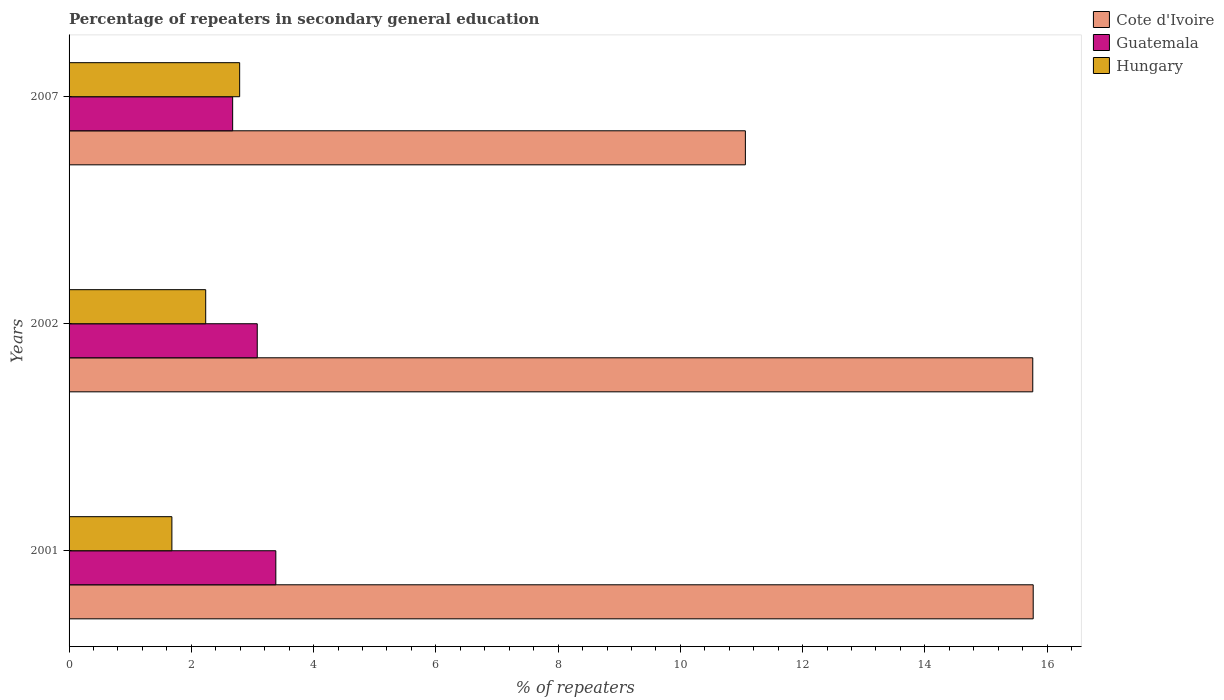How many different coloured bars are there?
Make the answer very short. 3. Are the number of bars per tick equal to the number of legend labels?
Ensure brevity in your answer.  Yes. How many bars are there on the 3rd tick from the top?
Provide a short and direct response. 3. How many bars are there on the 1st tick from the bottom?
Ensure brevity in your answer.  3. What is the percentage of repeaters in secondary general education in Cote d'Ivoire in 2002?
Give a very brief answer. 15.77. Across all years, what is the maximum percentage of repeaters in secondary general education in Hungary?
Your answer should be compact. 2.79. Across all years, what is the minimum percentage of repeaters in secondary general education in Hungary?
Give a very brief answer. 1.68. In which year was the percentage of repeaters in secondary general education in Hungary maximum?
Provide a succinct answer. 2007. What is the total percentage of repeaters in secondary general education in Guatemala in the graph?
Offer a very short reply. 9.14. What is the difference between the percentage of repeaters in secondary general education in Hungary in 2001 and that in 2007?
Provide a short and direct response. -1.11. What is the difference between the percentage of repeaters in secondary general education in Hungary in 2007 and the percentage of repeaters in secondary general education in Guatemala in 2001?
Ensure brevity in your answer.  -0.59. What is the average percentage of repeaters in secondary general education in Hungary per year?
Your response must be concise. 2.24. In the year 2002, what is the difference between the percentage of repeaters in secondary general education in Hungary and percentage of repeaters in secondary general education in Cote d'Ivoire?
Offer a very short reply. -13.53. What is the ratio of the percentage of repeaters in secondary general education in Cote d'Ivoire in 2002 to that in 2007?
Provide a short and direct response. 1.42. Is the percentage of repeaters in secondary general education in Guatemala in 2001 less than that in 2002?
Your answer should be compact. No. What is the difference between the highest and the second highest percentage of repeaters in secondary general education in Cote d'Ivoire?
Your response must be concise. 0.01. What is the difference between the highest and the lowest percentage of repeaters in secondary general education in Guatemala?
Provide a short and direct response. 0.71. In how many years, is the percentage of repeaters in secondary general education in Hungary greater than the average percentage of repeaters in secondary general education in Hungary taken over all years?
Your answer should be very brief. 1. What does the 3rd bar from the top in 2007 represents?
Offer a very short reply. Cote d'Ivoire. What does the 2nd bar from the bottom in 2002 represents?
Offer a terse response. Guatemala. Is it the case that in every year, the sum of the percentage of repeaters in secondary general education in Hungary and percentage of repeaters in secondary general education in Cote d'Ivoire is greater than the percentage of repeaters in secondary general education in Guatemala?
Provide a succinct answer. Yes. Are all the bars in the graph horizontal?
Make the answer very short. Yes. How many years are there in the graph?
Ensure brevity in your answer.  3. What is the difference between two consecutive major ticks on the X-axis?
Offer a terse response. 2. Does the graph contain any zero values?
Your answer should be very brief. No. Where does the legend appear in the graph?
Your answer should be very brief. Top right. How are the legend labels stacked?
Your answer should be very brief. Vertical. What is the title of the graph?
Ensure brevity in your answer.  Percentage of repeaters in secondary general education. Does "Mali" appear as one of the legend labels in the graph?
Offer a terse response. No. What is the label or title of the X-axis?
Offer a terse response. % of repeaters. What is the % of repeaters in Cote d'Ivoire in 2001?
Provide a succinct answer. 15.77. What is the % of repeaters in Guatemala in 2001?
Make the answer very short. 3.38. What is the % of repeaters in Hungary in 2001?
Offer a terse response. 1.68. What is the % of repeaters in Cote d'Ivoire in 2002?
Make the answer very short. 15.77. What is the % of repeaters in Guatemala in 2002?
Provide a succinct answer. 3.08. What is the % of repeaters in Hungary in 2002?
Offer a very short reply. 2.24. What is the % of repeaters in Cote d'Ivoire in 2007?
Offer a terse response. 11.06. What is the % of repeaters of Guatemala in 2007?
Your answer should be compact. 2.68. What is the % of repeaters in Hungary in 2007?
Provide a short and direct response. 2.79. Across all years, what is the maximum % of repeaters in Cote d'Ivoire?
Provide a short and direct response. 15.77. Across all years, what is the maximum % of repeaters of Guatemala?
Your answer should be compact. 3.38. Across all years, what is the maximum % of repeaters in Hungary?
Make the answer very short. 2.79. Across all years, what is the minimum % of repeaters in Cote d'Ivoire?
Make the answer very short. 11.06. Across all years, what is the minimum % of repeaters in Guatemala?
Give a very brief answer. 2.68. Across all years, what is the minimum % of repeaters in Hungary?
Your answer should be compact. 1.68. What is the total % of repeaters in Cote d'Ivoire in the graph?
Offer a very short reply. 42.6. What is the total % of repeaters in Guatemala in the graph?
Ensure brevity in your answer.  9.14. What is the total % of repeaters in Hungary in the graph?
Your response must be concise. 6.71. What is the difference between the % of repeaters in Cote d'Ivoire in 2001 and that in 2002?
Ensure brevity in your answer.  0.01. What is the difference between the % of repeaters in Guatemala in 2001 and that in 2002?
Your response must be concise. 0.3. What is the difference between the % of repeaters in Hungary in 2001 and that in 2002?
Provide a short and direct response. -0.55. What is the difference between the % of repeaters of Cote d'Ivoire in 2001 and that in 2007?
Your answer should be compact. 4.71. What is the difference between the % of repeaters in Guatemala in 2001 and that in 2007?
Offer a terse response. 0.71. What is the difference between the % of repeaters in Hungary in 2001 and that in 2007?
Make the answer very short. -1.11. What is the difference between the % of repeaters in Cote d'Ivoire in 2002 and that in 2007?
Provide a short and direct response. 4.7. What is the difference between the % of repeaters in Guatemala in 2002 and that in 2007?
Your answer should be very brief. 0.4. What is the difference between the % of repeaters in Hungary in 2002 and that in 2007?
Offer a terse response. -0.56. What is the difference between the % of repeaters in Cote d'Ivoire in 2001 and the % of repeaters in Guatemala in 2002?
Keep it short and to the point. 12.69. What is the difference between the % of repeaters in Cote d'Ivoire in 2001 and the % of repeaters in Hungary in 2002?
Your answer should be very brief. 13.54. What is the difference between the % of repeaters of Guatemala in 2001 and the % of repeaters of Hungary in 2002?
Your response must be concise. 1.15. What is the difference between the % of repeaters of Cote d'Ivoire in 2001 and the % of repeaters of Guatemala in 2007?
Give a very brief answer. 13.1. What is the difference between the % of repeaters of Cote d'Ivoire in 2001 and the % of repeaters of Hungary in 2007?
Give a very brief answer. 12.98. What is the difference between the % of repeaters in Guatemala in 2001 and the % of repeaters in Hungary in 2007?
Offer a terse response. 0.59. What is the difference between the % of repeaters in Cote d'Ivoire in 2002 and the % of repeaters in Guatemala in 2007?
Provide a short and direct response. 13.09. What is the difference between the % of repeaters of Cote d'Ivoire in 2002 and the % of repeaters of Hungary in 2007?
Offer a terse response. 12.97. What is the difference between the % of repeaters of Guatemala in 2002 and the % of repeaters of Hungary in 2007?
Offer a very short reply. 0.29. What is the average % of repeaters of Cote d'Ivoire per year?
Give a very brief answer. 14.2. What is the average % of repeaters of Guatemala per year?
Make the answer very short. 3.05. What is the average % of repeaters of Hungary per year?
Offer a terse response. 2.24. In the year 2001, what is the difference between the % of repeaters of Cote d'Ivoire and % of repeaters of Guatemala?
Your answer should be compact. 12.39. In the year 2001, what is the difference between the % of repeaters in Cote d'Ivoire and % of repeaters in Hungary?
Provide a short and direct response. 14.09. In the year 2001, what is the difference between the % of repeaters in Guatemala and % of repeaters in Hungary?
Keep it short and to the point. 1.7. In the year 2002, what is the difference between the % of repeaters in Cote d'Ivoire and % of repeaters in Guatemala?
Your answer should be compact. 12.69. In the year 2002, what is the difference between the % of repeaters in Cote d'Ivoire and % of repeaters in Hungary?
Provide a short and direct response. 13.53. In the year 2002, what is the difference between the % of repeaters of Guatemala and % of repeaters of Hungary?
Offer a very short reply. 0.84. In the year 2007, what is the difference between the % of repeaters of Cote d'Ivoire and % of repeaters of Guatemala?
Make the answer very short. 8.39. In the year 2007, what is the difference between the % of repeaters in Cote d'Ivoire and % of repeaters in Hungary?
Your response must be concise. 8.27. In the year 2007, what is the difference between the % of repeaters of Guatemala and % of repeaters of Hungary?
Your response must be concise. -0.11. What is the ratio of the % of repeaters in Cote d'Ivoire in 2001 to that in 2002?
Offer a very short reply. 1. What is the ratio of the % of repeaters of Guatemala in 2001 to that in 2002?
Your answer should be very brief. 1.1. What is the ratio of the % of repeaters of Hungary in 2001 to that in 2002?
Ensure brevity in your answer.  0.75. What is the ratio of the % of repeaters of Cote d'Ivoire in 2001 to that in 2007?
Ensure brevity in your answer.  1.43. What is the ratio of the % of repeaters of Guatemala in 2001 to that in 2007?
Your response must be concise. 1.26. What is the ratio of the % of repeaters in Hungary in 2001 to that in 2007?
Your answer should be compact. 0.6. What is the ratio of the % of repeaters of Cote d'Ivoire in 2002 to that in 2007?
Make the answer very short. 1.42. What is the ratio of the % of repeaters in Guatemala in 2002 to that in 2007?
Make the answer very short. 1.15. What is the ratio of the % of repeaters in Hungary in 2002 to that in 2007?
Your answer should be very brief. 0.8. What is the difference between the highest and the second highest % of repeaters of Cote d'Ivoire?
Ensure brevity in your answer.  0.01. What is the difference between the highest and the second highest % of repeaters of Guatemala?
Provide a succinct answer. 0.3. What is the difference between the highest and the second highest % of repeaters in Hungary?
Offer a very short reply. 0.56. What is the difference between the highest and the lowest % of repeaters of Cote d'Ivoire?
Provide a succinct answer. 4.71. What is the difference between the highest and the lowest % of repeaters in Guatemala?
Make the answer very short. 0.71. What is the difference between the highest and the lowest % of repeaters in Hungary?
Make the answer very short. 1.11. 